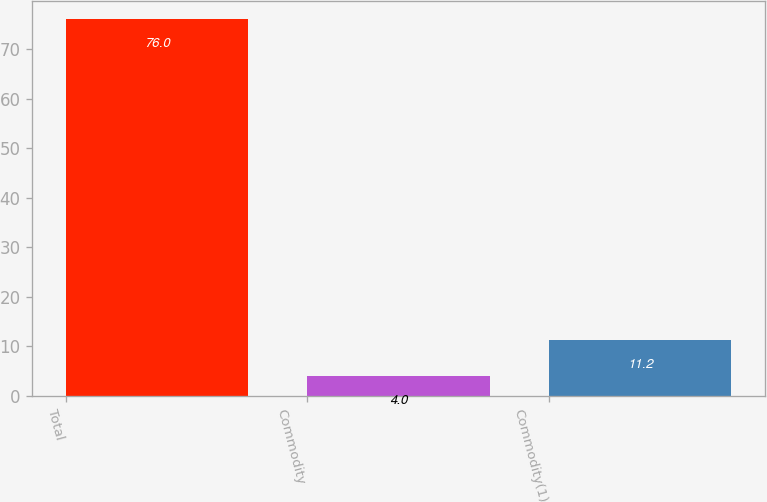<chart> <loc_0><loc_0><loc_500><loc_500><bar_chart><fcel>Total<fcel>Commodity<fcel>Commodity(1)<nl><fcel>76<fcel>4<fcel>11.2<nl></chart> 